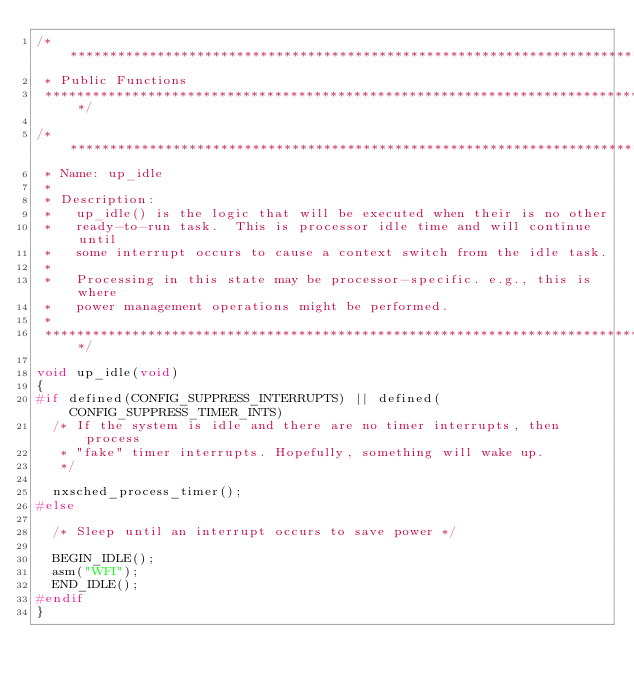Convert code to text. <code><loc_0><loc_0><loc_500><loc_500><_C_>/****************************************************************************
 * Public Functions
 ****************************************************************************/

/****************************************************************************
 * Name: up_idle
 *
 * Description:
 *   up_idle() is the logic that will be executed when their is no other
 *   ready-to-run task.  This is processor idle time and will continue until
 *   some interrupt occurs to cause a context switch from the idle task.
 *
 *   Processing in this state may be processor-specific. e.g., this is where
 *   power management operations might be performed.
 *
 ****************************************************************************/

void up_idle(void)
{
#if defined(CONFIG_SUPPRESS_INTERRUPTS) || defined(CONFIG_SUPPRESS_TIMER_INTS)
  /* If the system is idle and there are no timer interrupts, then process
   * "fake" timer interrupts. Hopefully, something will wake up.
   */

  nxsched_process_timer();
#else

  /* Sleep until an interrupt occurs to save power */

  BEGIN_IDLE();
  asm("WFI");
  END_IDLE();
#endif
}
</code> 